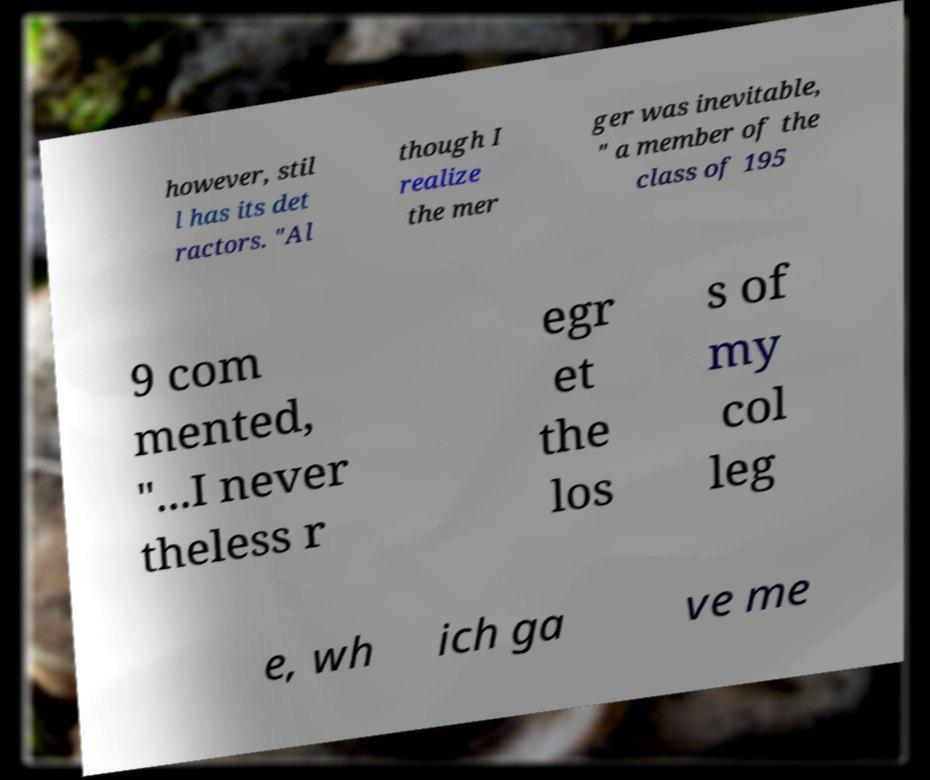Please read and relay the text visible in this image. What does it say? however, stil l has its det ractors. "Al though I realize the mer ger was inevitable, " a member of the class of 195 9 com mented, "...I never theless r egr et the los s of my col leg e, wh ich ga ve me 